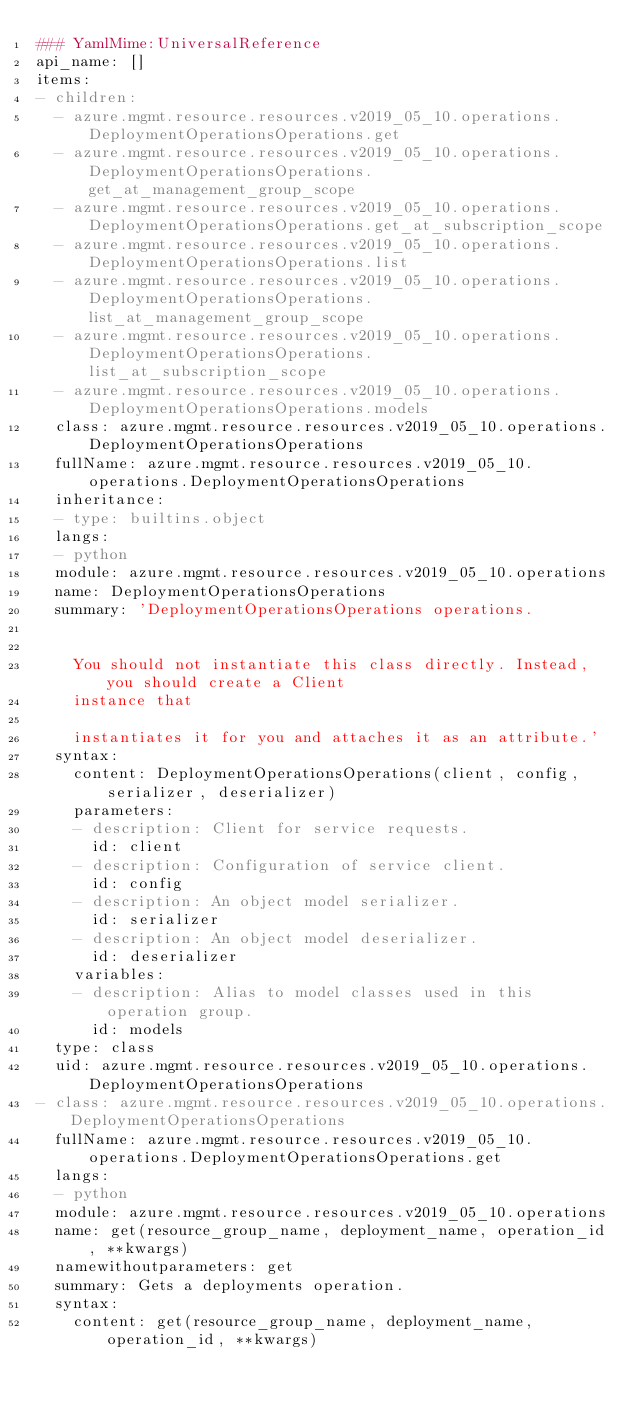<code> <loc_0><loc_0><loc_500><loc_500><_YAML_>### YamlMime:UniversalReference
api_name: []
items:
- children:
  - azure.mgmt.resource.resources.v2019_05_10.operations.DeploymentOperationsOperations.get
  - azure.mgmt.resource.resources.v2019_05_10.operations.DeploymentOperationsOperations.get_at_management_group_scope
  - azure.mgmt.resource.resources.v2019_05_10.operations.DeploymentOperationsOperations.get_at_subscription_scope
  - azure.mgmt.resource.resources.v2019_05_10.operations.DeploymentOperationsOperations.list
  - azure.mgmt.resource.resources.v2019_05_10.operations.DeploymentOperationsOperations.list_at_management_group_scope
  - azure.mgmt.resource.resources.v2019_05_10.operations.DeploymentOperationsOperations.list_at_subscription_scope
  - azure.mgmt.resource.resources.v2019_05_10.operations.DeploymentOperationsOperations.models
  class: azure.mgmt.resource.resources.v2019_05_10.operations.DeploymentOperationsOperations
  fullName: azure.mgmt.resource.resources.v2019_05_10.operations.DeploymentOperationsOperations
  inheritance:
  - type: builtins.object
  langs:
  - python
  module: azure.mgmt.resource.resources.v2019_05_10.operations
  name: DeploymentOperationsOperations
  summary: 'DeploymentOperationsOperations operations.


    You should not instantiate this class directly. Instead, you should create a Client
    instance that

    instantiates it for you and attaches it as an attribute.'
  syntax:
    content: DeploymentOperationsOperations(client, config, serializer, deserializer)
    parameters:
    - description: Client for service requests.
      id: client
    - description: Configuration of service client.
      id: config
    - description: An object model serializer.
      id: serializer
    - description: An object model deserializer.
      id: deserializer
    variables:
    - description: Alias to model classes used in this operation group.
      id: models
  type: class
  uid: azure.mgmt.resource.resources.v2019_05_10.operations.DeploymentOperationsOperations
- class: azure.mgmt.resource.resources.v2019_05_10.operations.DeploymentOperationsOperations
  fullName: azure.mgmt.resource.resources.v2019_05_10.operations.DeploymentOperationsOperations.get
  langs:
  - python
  module: azure.mgmt.resource.resources.v2019_05_10.operations
  name: get(resource_group_name, deployment_name, operation_id, **kwargs)
  namewithoutparameters: get
  summary: Gets a deployments operation.
  syntax:
    content: get(resource_group_name, deployment_name, operation_id, **kwargs)</code> 